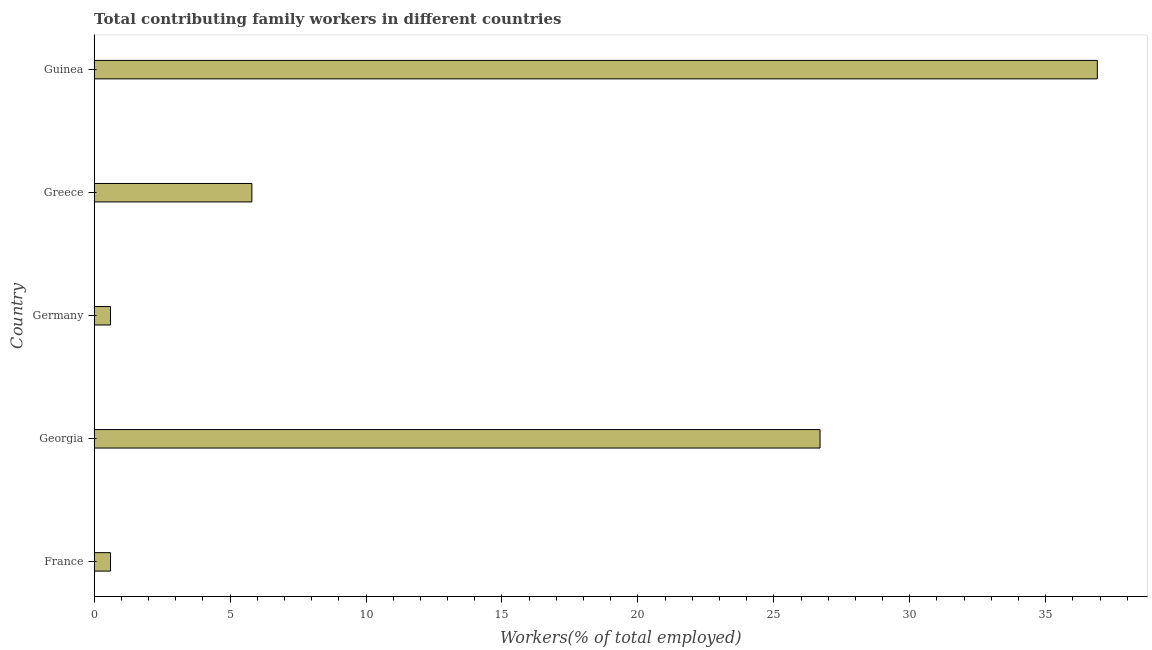Does the graph contain any zero values?
Ensure brevity in your answer.  No. Does the graph contain grids?
Keep it short and to the point. No. What is the title of the graph?
Your response must be concise. Total contributing family workers in different countries. What is the label or title of the X-axis?
Make the answer very short. Workers(% of total employed). What is the label or title of the Y-axis?
Your answer should be compact. Country. What is the contributing family workers in Greece?
Ensure brevity in your answer.  5.8. Across all countries, what is the maximum contributing family workers?
Make the answer very short. 36.9. Across all countries, what is the minimum contributing family workers?
Provide a short and direct response. 0.6. In which country was the contributing family workers maximum?
Your answer should be very brief. Guinea. In which country was the contributing family workers minimum?
Your response must be concise. France. What is the sum of the contributing family workers?
Your response must be concise. 70.6. What is the difference between the contributing family workers in France and Georgia?
Keep it short and to the point. -26.1. What is the average contributing family workers per country?
Make the answer very short. 14.12. What is the median contributing family workers?
Make the answer very short. 5.8. In how many countries, is the contributing family workers greater than 3 %?
Your response must be concise. 3. What is the ratio of the contributing family workers in Germany to that in Guinea?
Give a very brief answer. 0.02. What is the difference between the highest and the second highest contributing family workers?
Ensure brevity in your answer.  10.2. What is the difference between the highest and the lowest contributing family workers?
Give a very brief answer. 36.3. How many countries are there in the graph?
Offer a terse response. 5. What is the difference between two consecutive major ticks on the X-axis?
Your answer should be compact. 5. Are the values on the major ticks of X-axis written in scientific E-notation?
Offer a very short reply. No. What is the Workers(% of total employed) in France?
Your response must be concise. 0.6. What is the Workers(% of total employed) in Georgia?
Offer a very short reply. 26.7. What is the Workers(% of total employed) of Germany?
Offer a very short reply. 0.6. What is the Workers(% of total employed) in Greece?
Offer a very short reply. 5.8. What is the Workers(% of total employed) of Guinea?
Your answer should be compact. 36.9. What is the difference between the Workers(% of total employed) in France and Georgia?
Provide a short and direct response. -26.1. What is the difference between the Workers(% of total employed) in France and Germany?
Offer a very short reply. 0. What is the difference between the Workers(% of total employed) in France and Greece?
Your response must be concise. -5.2. What is the difference between the Workers(% of total employed) in France and Guinea?
Your answer should be very brief. -36.3. What is the difference between the Workers(% of total employed) in Georgia and Germany?
Your answer should be very brief. 26.1. What is the difference between the Workers(% of total employed) in Georgia and Greece?
Your answer should be compact. 20.9. What is the difference between the Workers(% of total employed) in Germany and Greece?
Give a very brief answer. -5.2. What is the difference between the Workers(% of total employed) in Germany and Guinea?
Offer a terse response. -36.3. What is the difference between the Workers(% of total employed) in Greece and Guinea?
Your response must be concise. -31.1. What is the ratio of the Workers(% of total employed) in France to that in Georgia?
Provide a short and direct response. 0.02. What is the ratio of the Workers(% of total employed) in France to that in Germany?
Your answer should be compact. 1. What is the ratio of the Workers(% of total employed) in France to that in Greece?
Keep it short and to the point. 0.1. What is the ratio of the Workers(% of total employed) in France to that in Guinea?
Offer a very short reply. 0.02. What is the ratio of the Workers(% of total employed) in Georgia to that in Germany?
Provide a succinct answer. 44.5. What is the ratio of the Workers(% of total employed) in Georgia to that in Greece?
Your response must be concise. 4.6. What is the ratio of the Workers(% of total employed) in Georgia to that in Guinea?
Your response must be concise. 0.72. What is the ratio of the Workers(% of total employed) in Germany to that in Greece?
Ensure brevity in your answer.  0.1. What is the ratio of the Workers(% of total employed) in Germany to that in Guinea?
Offer a very short reply. 0.02. What is the ratio of the Workers(% of total employed) in Greece to that in Guinea?
Provide a short and direct response. 0.16. 